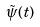Convert formula to latex. <formula><loc_0><loc_0><loc_500><loc_500>\tilde { \psi } ( t )</formula> 